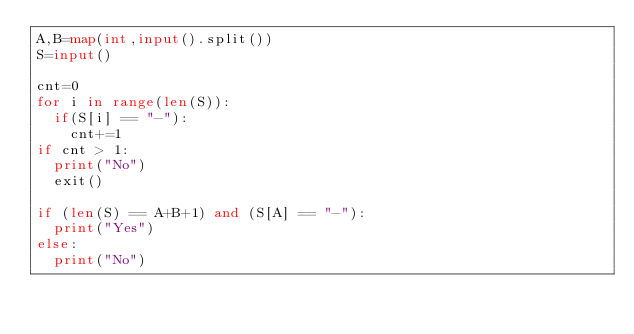<code> <loc_0><loc_0><loc_500><loc_500><_Python_>A,B=map(int,input().split())
S=input()

cnt=0
for i in range(len(S)):
  if(S[i] == "-"):
    cnt+=1
if cnt > 1:
  print("No")
  exit()

if (len(S) == A+B+1) and (S[A] == "-"):
  print("Yes")
else:
  print("No")</code> 